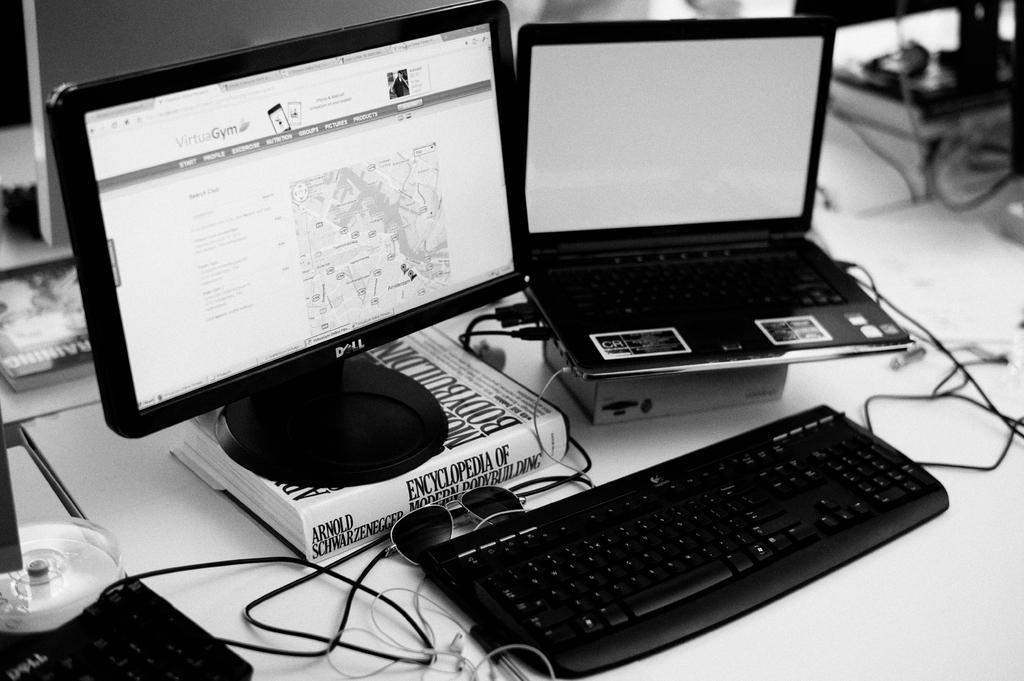How would you summarize this image in a sentence or two? In this image i can see a desktop, a keyboard on a table. 